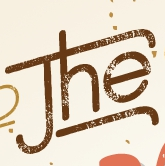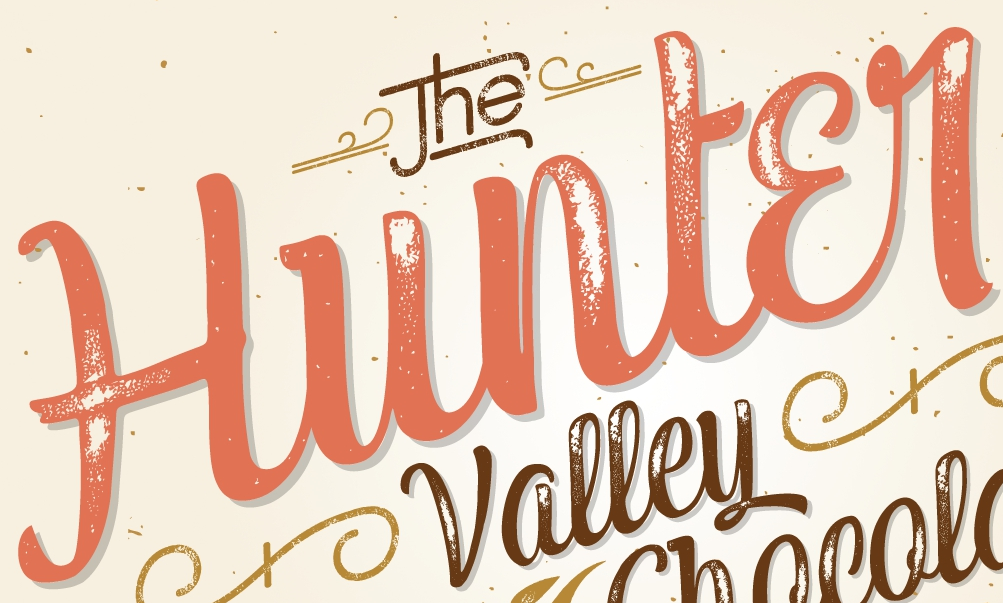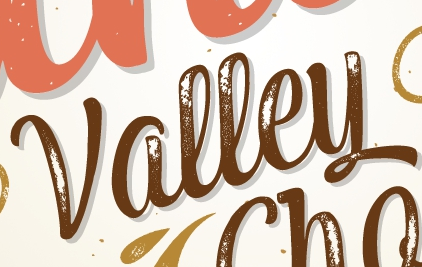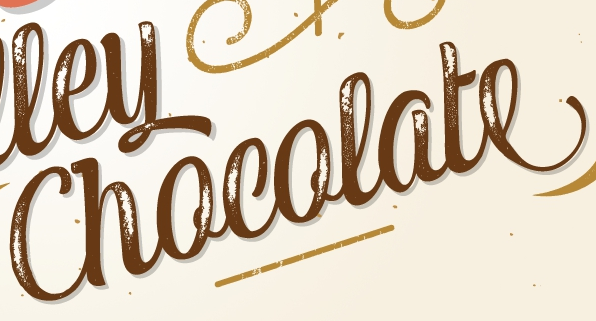What words can you see in these images in sequence, separated by a semicolon? The; Hunter; Valley; Chocolate 